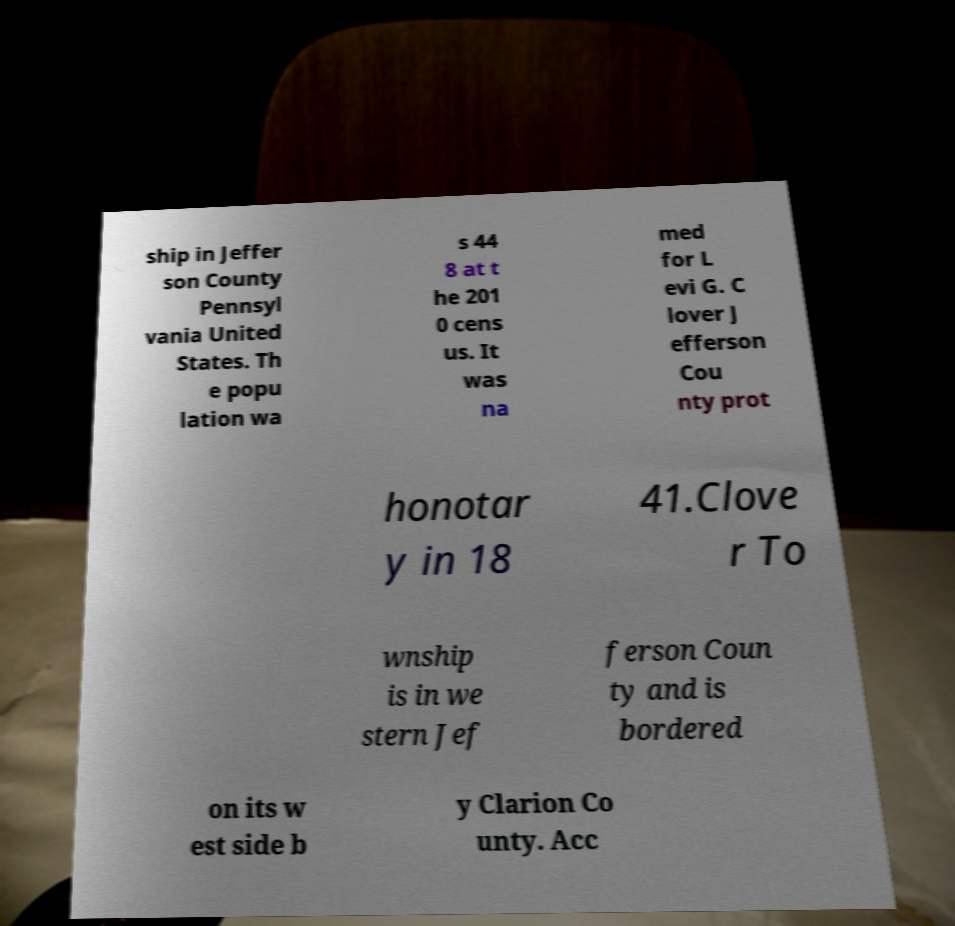I need the written content from this picture converted into text. Can you do that? ship in Jeffer son County Pennsyl vania United States. Th e popu lation wa s 44 8 at t he 201 0 cens us. It was na med for L evi G. C lover J efferson Cou nty prot honotar y in 18 41.Clove r To wnship is in we stern Jef ferson Coun ty and is bordered on its w est side b y Clarion Co unty. Acc 